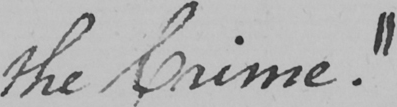What is written in this line of handwriting? the Crime . " 